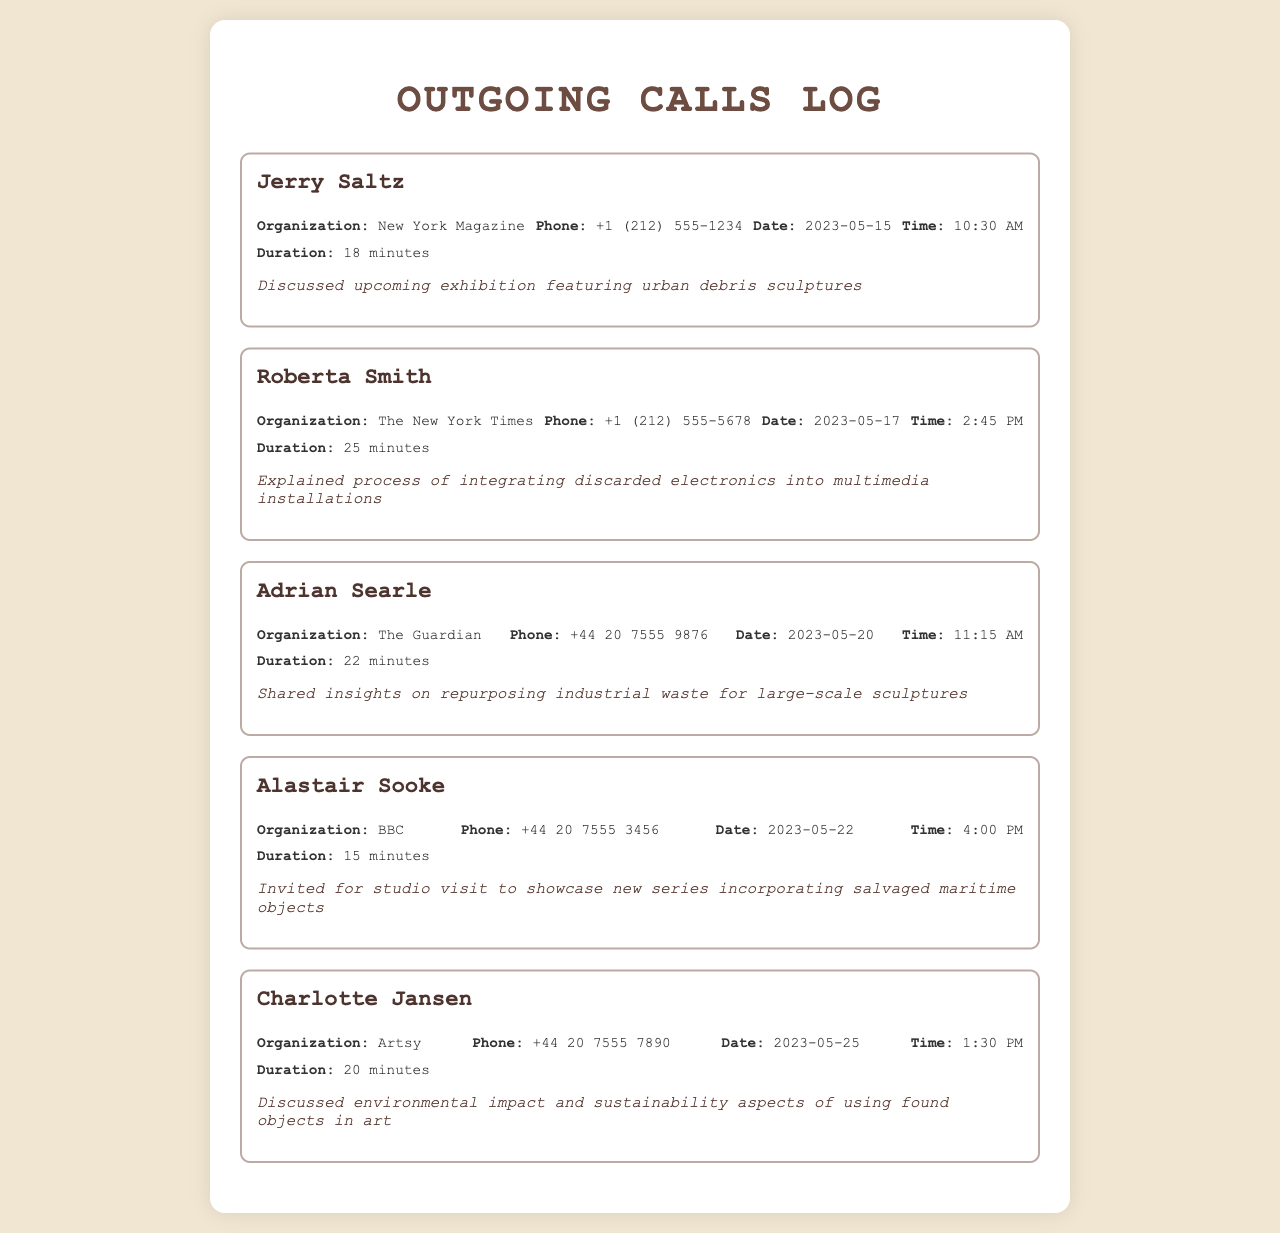what is the name of the first critic called? The first critic listed in the document is Jerry Saltz.
Answer: Jerry Saltz which organization does Roberta Smith represent? Roberta Smith represents The New York Times as listed in the call records.
Answer: The New York Times how long was the call with Adrian Searle? The duration of the call with Adrian Searle was 22 minutes.
Answer: 22 minutes on what date did you discuss sustainability with Charlotte Jansen? The discussion on sustainability with Charlotte Jansen took place on May 25, 2023.
Answer: 2023-05-25 how many minutes was the shortest call listed? The shortest call lasted 15 minutes as stated in the records.
Answer: 15 minutes what type of objects were discussed in the call with Alastair Sooke? In the call with Alastair Sooke, salvaged maritime objects were discussed.
Answer: salvaged maritime objects which journalist invited you for a studio visit? Alastair Sooke invited for a studio visit according to the document.
Answer: Alastair Sooke what was the main focus of the call with Jerry Saltz? The main focus of the call with Jerry Saltz was on urban debris sculptures.
Answer: urban debris sculptures how many total calls are recorded in this document? There are a total of five calls recorded in the document.
Answer: five 